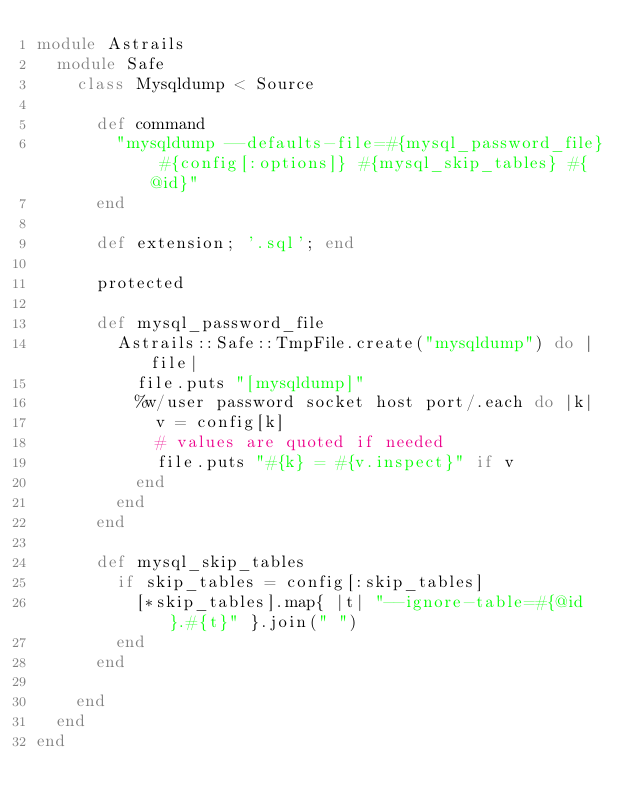Convert code to text. <code><loc_0><loc_0><loc_500><loc_500><_Ruby_>module Astrails
  module Safe
    class Mysqldump < Source

      def command
        "mysqldump --defaults-file=#{mysql_password_file} #{config[:options]} #{mysql_skip_tables} #{@id}"
      end

      def extension; '.sql'; end

      protected

      def mysql_password_file
        Astrails::Safe::TmpFile.create("mysqldump") do |file|
          file.puts "[mysqldump]"
          %w/user password socket host port/.each do |k|
            v = config[k]
            # values are quoted if needed
            file.puts "#{k} = #{v.inspect}" if v
          end
        end
      end

      def mysql_skip_tables
        if skip_tables = config[:skip_tables]
          [*skip_tables].map{ |t| "--ignore-table=#{@id}.#{t}" }.join(" ")
        end
      end

    end
  end
end</code> 